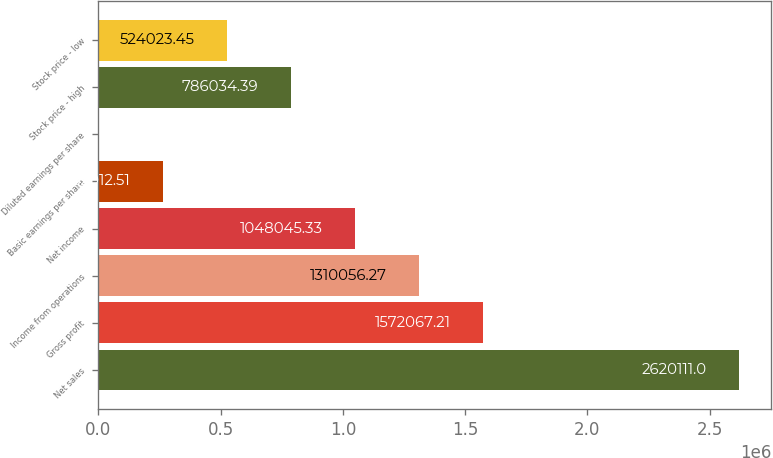<chart> <loc_0><loc_0><loc_500><loc_500><bar_chart><fcel>Net sales<fcel>Gross profit<fcel>Income from operations<fcel>Net income<fcel>Basic earnings per share<fcel>Diluted earnings per share<fcel>Stock price - high<fcel>Stock price - low<nl><fcel>2.62011e+06<fcel>1.57207e+06<fcel>1.31006e+06<fcel>1.04805e+06<fcel>262013<fcel>1.57<fcel>786034<fcel>524023<nl></chart> 